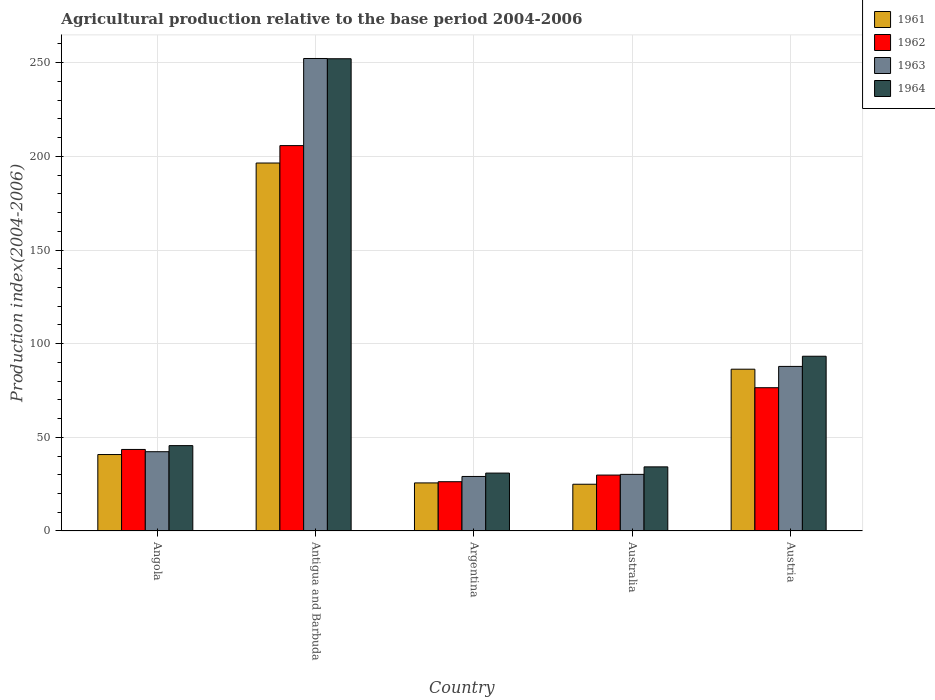How many different coloured bars are there?
Provide a succinct answer. 4. Are the number of bars on each tick of the X-axis equal?
Offer a very short reply. Yes. What is the label of the 1st group of bars from the left?
Make the answer very short. Angola. In how many cases, is the number of bars for a given country not equal to the number of legend labels?
Offer a terse response. 0. What is the agricultural production index in 1963 in Argentina?
Ensure brevity in your answer.  29.11. Across all countries, what is the maximum agricultural production index in 1964?
Ensure brevity in your answer.  252.1. Across all countries, what is the minimum agricultural production index in 1964?
Keep it short and to the point. 30.91. In which country was the agricultural production index in 1961 maximum?
Your answer should be compact. Antigua and Barbuda. What is the total agricultural production index in 1962 in the graph?
Provide a succinct answer. 381.91. What is the difference between the agricultural production index in 1961 in Argentina and that in Austria?
Offer a very short reply. -60.7. What is the difference between the agricultural production index in 1964 in Antigua and Barbuda and the agricultural production index in 1963 in Argentina?
Ensure brevity in your answer.  222.99. What is the average agricultural production index in 1963 per country?
Ensure brevity in your answer.  88.35. What is the difference between the agricultural production index of/in 1963 and agricultural production index of/in 1962 in Australia?
Your response must be concise. 0.38. What is the ratio of the agricultural production index in 1964 in Angola to that in Argentina?
Provide a short and direct response. 1.47. Is the difference between the agricultural production index in 1963 in Argentina and Australia greater than the difference between the agricultural production index in 1962 in Argentina and Australia?
Keep it short and to the point. Yes. What is the difference between the highest and the second highest agricultural production index in 1962?
Ensure brevity in your answer.  -32.96. What is the difference between the highest and the lowest agricultural production index in 1961?
Provide a succinct answer. 171.47. In how many countries, is the agricultural production index in 1964 greater than the average agricultural production index in 1964 taken over all countries?
Ensure brevity in your answer.  2. What does the 4th bar from the right in Argentina represents?
Your answer should be compact. 1961. Is it the case that in every country, the sum of the agricultural production index in 1961 and agricultural production index in 1963 is greater than the agricultural production index in 1964?
Provide a succinct answer. Yes. How many bars are there?
Your response must be concise. 20. What is the difference between two consecutive major ticks on the Y-axis?
Your answer should be compact. 50. Where does the legend appear in the graph?
Provide a short and direct response. Top right. What is the title of the graph?
Your answer should be compact. Agricultural production relative to the base period 2004-2006. What is the label or title of the X-axis?
Make the answer very short. Country. What is the label or title of the Y-axis?
Provide a succinct answer. Production index(2004-2006). What is the Production index(2004-2006) in 1961 in Angola?
Ensure brevity in your answer.  40.81. What is the Production index(2004-2006) of 1962 in Angola?
Ensure brevity in your answer.  43.53. What is the Production index(2004-2006) in 1963 in Angola?
Offer a terse response. 42.32. What is the Production index(2004-2006) in 1964 in Angola?
Keep it short and to the point. 45.58. What is the Production index(2004-2006) in 1961 in Antigua and Barbuda?
Ensure brevity in your answer.  196.43. What is the Production index(2004-2006) of 1962 in Antigua and Barbuda?
Give a very brief answer. 205.73. What is the Production index(2004-2006) in 1963 in Antigua and Barbuda?
Your answer should be very brief. 252.23. What is the Production index(2004-2006) of 1964 in Antigua and Barbuda?
Keep it short and to the point. 252.1. What is the Production index(2004-2006) in 1961 in Argentina?
Your answer should be very brief. 25.67. What is the Production index(2004-2006) of 1962 in Argentina?
Your answer should be compact. 26.31. What is the Production index(2004-2006) in 1963 in Argentina?
Offer a terse response. 29.11. What is the Production index(2004-2006) in 1964 in Argentina?
Your answer should be very brief. 30.91. What is the Production index(2004-2006) of 1961 in Australia?
Make the answer very short. 24.96. What is the Production index(2004-2006) of 1962 in Australia?
Offer a very short reply. 29.85. What is the Production index(2004-2006) of 1963 in Australia?
Provide a short and direct response. 30.23. What is the Production index(2004-2006) of 1964 in Australia?
Your answer should be compact. 34.23. What is the Production index(2004-2006) of 1961 in Austria?
Provide a short and direct response. 86.37. What is the Production index(2004-2006) of 1962 in Austria?
Provide a succinct answer. 76.49. What is the Production index(2004-2006) in 1963 in Austria?
Provide a succinct answer. 87.86. What is the Production index(2004-2006) of 1964 in Austria?
Ensure brevity in your answer.  93.29. Across all countries, what is the maximum Production index(2004-2006) in 1961?
Make the answer very short. 196.43. Across all countries, what is the maximum Production index(2004-2006) in 1962?
Provide a short and direct response. 205.73. Across all countries, what is the maximum Production index(2004-2006) of 1963?
Provide a succinct answer. 252.23. Across all countries, what is the maximum Production index(2004-2006) of 1964?
Provide a succinct answer. 252.1. Across all countries, what is the minimum Production index(2004-2006) of 1961?
Keep it short and to the point. 24.96. Across all countries, what is the minimum Production index(2004-2006) of 1962?
Give a very brief answer. 26.31. Across all countries, what is the minimum Production index(2004-2006) of 1963?
Offer a very short reply. 29.11. Across all countries, what is the minimum Production index(2004-2006) in 1964?
Keep it short and to the point. 30.91. What is the total Production index(2004-2006) in 1961 in the graph?
Ensure brevity in your answer.  374.24. What is the total Production index(2004-2006) of 1962 in the graph?
Ensure brevity in your answer.  381.91. What is the total Production index(2004-2006) of 1963 in the graph?
Ensure brevity in your answer.  441.75. What is the total Production index(2004-2006) of 1964 in the graph?
Provide a short and direct response. 456.11. What is the difference between the Production index(2004-2006) in 1961 in Angola and that in Antigua and Barbuda?
Keep it short and to the point. -155.62. What is the difference between the Production index(2004-2006) in 1962 in Angola and that in Antigua and Barbuda?
Your answer should be very brief. -162.2. What is the difference between the Production index(2004-2006) in 1963 in Angola and that in Antigua and Barbuda?
Provide a short and direct response. -209.91. What is the difference between the Production index(2004-2006) in 1964 in Angola and that in Antigua and Barbuda?
Offer a terse response. -206.52. What is the difference between the Production index(2004-2006) of 1961 in Angola and that in Argentina?
Make the answer very short. 15.14. What is the difference between the Production index(2004-2006) of 1962 in Angola and that in Argentina?
Make the answer very short. 17.22. What is the difference between the Production index(2004-2006) in 1963 in Angola and that in Argentina?
Your response must be concise. 13.21. What is the difference between the Production index(2004-2006) of 1964 in Angola and that in Argentina?
Your answer should be very brief. 14.67. What is the difference between the Production index(2004-2006) in 1961 in Angola and that in Australia?
Your response must be concise. 15.85. What is the difference between the Production index(2004-2006) of 1962 in Angola and that in Australia?
Your response must be concise. 13.68. What is the difference between the Production index(2004-2006) of 1963 in Angola and that in Australia?
Ensure brevity in your answer.  12.09. What is the difference between the Production index(2004-2006) of 1964 in Angola and that in Australia?
Offer a very short reply. 11.35. What is the difference between the Production index(2004-2006) in 1961 in Angola and that in Austria?
Your response must be concise. -45.56. What is the difference between the Production index(2004-2006) in 1962 in Angola and that in Austria?
Provide a short and direct response. -32.96. What is the difference between the Production index(2004-2006) of 1963 in Angola and that in Austria?
Ensure brevity in your answer.  -45.54. What is the difference between the Production index(2004-2006) of 1964 in Angola and that in Austria?
Your answer should be compact. -47.71. What is the difference between the Production index(2004-2006) of 1961 in Antigua and Barbuda and that in Argentina?
Your answer should be compact. 170.76. What is the difference between the Production index(2004-2006) in 1962 in Antigua and Barbuda and that in Argentina?
Your response must be concise. 179.42. What is the difference between the Production index(2004-2006) of 1963 in Antigua and Barbuda and that in Argentina?
Give a very brief answer. 223.12. What is the difference between the Production index(2004-2006) in 1964 in Antigua and Barbuda and that in Argentina?
Provide a succinct answer. 221.19. What is the difference between the Production index(2004-2006) in 1961 in Antigua and Barbuda and that in Australia?
Your answer should be very brief. 171.47. What is the difference between the Production index(2004-2006) in 1962 in Antigua and Barbuda and that in Australia?
Offer a very short reply. 175.88. What is the difference between the Production index(2004-2006) of 1963 in Antigua and Barbuda and that in Australia?
Offer a very short reply. 222. What is the difference between the Production index(2004-2006) in 1964 in Antigua and Barbuda and that in Australia?
Your answer should be very brief. 217.87. What is the difference between the Production index(2004-2006) of 1961 in Antigua and Barbuda and that in Austria?
Make the answer very short. 110.06. What is the difference between the Production index(2004-2006) in 1962 in Antigua and Barbuda and that in Austria?
Provide a succinct answer. 129.24. What is the difference between the Production index(2004-2006) in 1963 in Antigua and Barbuda and that in Austria?
Your response must be concise. 164.37. What is the difference between the Production index(2004-2006) in 1964 in Antigua and Barbuda and that in Austria?
Your answer should be compact. 158.81. What is the difference between the Production index(2004-2006) in 1961 in Argentina and that in Australia?
Your answer should be very brief. 0.71. What is the difference between the Production index(2004-2006) in 1962 in Argentina and that in Australia?
Your response must be concise. -3.54. What is the difference between the Production index(2004-2006) of 1963 in Argentina and that in Australia?
Keep it short and to the point. -1.12. What is the difference between the Production index(2004-2006) in 1964 in Argentina and that in Australia?
Ensure brevity in your answer.  -3.32. What is the difference between the Production index(2004-2006) of 1961 in Argentina and that in Austria?
Make the answer very short. -60.7. What is the difference between the Production index(2004-2006) in 1962 in Argentina and that in Austria?
Make the answer very short. -50.18. What is the difference between the Production index(2004-2006) of 1963 in Argentina and that in Austria?
Offer a terse response. -58.75. What is the difference between the Production index(2004-2006) of 1964 in Argentina and that in Austria?
Keep it short and to the point. -62.38. What is the difference between the Production index(2004-2006) in 1961 in Australia and that in Austria?
Keep it short and to the point. -61.41. What is the difference between the Production index(2004-2006) in 1962 in Australia and that in Austria?
Your answer should be compact. -46.64. What is the difference between the Production index(2004-2006) in 1963 in Australia and that in Austria?
Keep it short and to the point. -57.63. What is the difference between the Production index(2004-2006) of 1964 in Australia and that in Austria?
Provide a short and direct response. -59.06. What is the difference between the Production index(2004-2006) in 1961 in Angola and the Production index(2004-2006) in 1962 in Antigua and Barbuda?
Provide a succinct answer. -164.92. What is the difference between the Production index(2004-2006) of 1961 in Angola and the Production index(2004-2006) of 1963 in Antigua and Barbuda?
Make the answer very short. -211.42. What is the difference between the Production index(2004-2006) of 1961 in Angola and the Production index(2004-2006) of 1964 in Antigua and Barbuda?
Offer a terse response. -211.29. What is the difference between the Production index(2004-2006) in 1962 in Angola and the Production index(2004-2006) in 1963 in Antigua and Barbuda?
Offer a terse response. -208.7. What is the difference between the Production index(2004-2006) of 1962 in Angola and the Production index(2004-2006) of 1964 in Antigua and Barbuda?
Provide a short and direct response. -208.57. What is the difference between the Production index(2004-2006) in 1963 in Angola and the Production index(2004-2006) in 1964 in Antigua and Barbuda?
Provide a short and direct response. -209.78. What is the difference between the Production index(2004-2006) in 1961 in Angola and the Production index(2004-2006) in 1963 in Argentina?
Provide a succinct answer. 11.7. What is the difference between the Production index(2004-2006) in 1961 in Angola and the Production index(2004-2006) in 1964 in Argentina?
Your answer should be very brief. 9.9. What is the difference between the Production index(2004-2006) in 1962 in Angola and the Production index(2004-2006) in 1963 in Argentina?
Offer a terse response. 14.42. What is the difference between the Production index(2004-2006) in 1962 in Angola and the Production index(2004-2006) in 1964 in Argentina?
Your answer should be compact. 12.62. What is the difference between the Production index(2004-2006) in 1963 in Angola and the Production index(2004-2006) in 1964 in Argentina?
Offer a terse response. 11.41. What is the difference between the Production index(2004-2006) in 1961 in Angola and the Production index(2004-2006) in 1962 in Australia?
Give a very brief answer. 10.96. What is the difference between the Production index(2004-2006) of 1961 in Angola and the Production index(2004-2006) of 1963 in Australia?
Your answer should be compact. 10.58. What is the difference between the Production index(2004-2006) of 1961 in Angola and the Production index(2004-2006) of 1964 in Australia?
Keep it short and to the point. 6.58. What is the difference between the Production index(2004-2006) of 1963 in Angola and the Production index(2004-2006) of 1964 in Australia?
Your answer should be very brief. 8.09. What is the difference between the Production index(2004-2006) in 1961 in Angola and the Production index(2004-2006) in 1962 in Austria?
Give a very brief answer. -35.68. What is the difference between the Production index(2004-2006) in 1961 in Angola and the Production index(2004-2006) in 1963 in Austria?
Make the answer very short. -47.05. What is the difference between the Production index(2004-2006) in 1961 in Angola and the Production index(2004-2006) in 1964 in Austria?
Ensure brevity in your answer.  -52.48. What is the difference between the Production index(2004-2006) of 1962 in Angola and the Production index(2004-2006) of 1963 in Austria?
Your answer should be very brief. -44.33. What is the difference between the Production index(2004-2006) of 1962 in Angola and the Production index(2004-2006) of 1964 in Austria?
Keep it short and to the point. -49.76. What is the difference between the Production index(2004-2006) in 1963 in Angola and the Production index(2004-2006) in 1964 in Austria?
Your answer should be compact. -50.97. What is the difference between the Production index(2004-2006) of 1961 in Antigua and Barbuda and the Production index(2004-2006) of 1962 in Argentina?
Offer a terse response. 170.12. What is the difference between the Production index(2004-2006) in 1961 in Antigua and Barbuda and the Production index(2004-2006) in 1963 in Argentina?
Your answer should be compact. 167.32. What is the difference between the Production index(2004-2006) of 1961 in Antigua and Barbuda and the Production index(2004-2006) of 1964 in Argentina?
Your answer should be compact. 165.52. What is the difference between the Production index(2004-2006) in 1962 in Antigua and Barbuda and the Production index(2004-2006) in 1963 in Argentina?
Your response must be concise. 176.62. What is the difference between the Production index(2004-2006) of 1962 in Antigua and Barbuda and the Production index(2004-2006) of 1964 in Argentina?
Ensure brevity in your answer.  174.82. What is the difference between the Production index(2004-2006) in 1963 in Antigua and Barbuda and the Production index(2004-2006) in 1964 in Argentina?
Your answer should be compact. 221.32. What is the difference between the Production index(2004-2006) in 1961 in Antigua and Barbuda and the Production index(2004-2006) in 1962 in Australia?
Give a very brief answer. 166.58. What is the difference between the Production index(2004-2006) in 1961 in Antigua and Barbuda and the Production index(2004-2006) in 1963 in Australia?
Give a very brief answer. 166.2. What is the difference between the Production index(2004-2006) in 1961 in Antigua and Barbuda and the Production index(2004-2006) in 1964 in Australia?
Your answer should be very brief. 162.2. What is the difference between the Production index(2004-2006) of 1962 in Antigua and Barbuda and the Production index(2004-2006) of 1963 in Australia?
Keep it short and to the point. 175.5. What is the difference between the Production index(2004-2006) in 1962 in Antigua and Barbuda and the Production index(2004-2006) in 1964 in Australia?
Your answer should be compact. 171.5. What is the difference between the Production index(2004-2006) of 1963 in Antigua and Barbuda and the Production index(2004-2006) of 1964 in Australia?
Offer a terse response. 218. What is the difference between the Production index(2004-2006) in 1961 in Antigua and Barbuda and the Production index(2004-2006) in 1962 in Austria?
Ensure brevity in your answer.  119.94. What is the difference between the Production index(2004-2006) in 1961 in Antigua and Barbuda and the Production index(2004-2006) in 1963 in Austria?
Provide a succinct answer. 108.57. What is the difference between the Production index(2004-2006) in 1961 in Antigua and Barbuda and the Production index(2004-2006) in 1964 in Austria?
Offer a terse response. 103.14. What is the difference between the Production index(2004-2006) in 1962 in Antigua and Barbuda and the Production index(2004-2006) in 1963 in Austria?
Provide a short and direct response. 117.87. What is the difference between the Production index(2004-2006) in 1962 in Antigua and Barbuda and the Production index(2004-2006) in 1964 in Austria?
Your response must be concise. 112.44. What is the difference between the Production index(2004-2006) of 1963 in Antigua and Barbuda and the Production index(2004-2006) of 1964 in Austria?
Your response must be concise. 158.94. What is the difference between the Production index(2004-2006) of 1961 in Argentina and the Production index(2004-2006) of 1962 in Australia?
Provide a short and direct response. -4.18. What is the difference between the Production index(2004-2006) in 1961 in Argentina and the Production index(2004-2006) in 1963 in Australia?
Provide a short and direct response. -4.56. What is the difference between the Production index(2004-2006) in 1961 in Argentina and the Production index(2004-2006) in 1964 in Australia?
Your answer should be compact. -8.56. What is the difference between the Production index(2004-2006) in 1962 in Argentina and the Production index(2004-2006) in 1963 in Australia?
Keep it short and to the point. -3.92. What is the difference between the Production index(2004-2006) of 1962 in Argentina and the Production index(2004-2006) of 1964 in Australia?
Provide a short and direct response. -7.92. What is the difference between the Production index(2004-2006) of 1963 in Argentina and the Production index(2004-2006) of 1964 in Australia?
Keep it short and to the point. -5.12. What is the difference between the Production index(2004-2006) of 1961 in Argentina and the Production index(2004-2006) of 1962 in Austria?
Offer a terse response. -50.82. What is the difference between the Production index(2004-2006) in 1961 in Argentina and the Production index(2004-2006) in 1963 in Austria?
Ensure brevity in your answer.  -62.19. What is the difference between the Production index(2004-2006) in 1961 in Argentina and the Production index(2004-2006) in 1964 in Austria?
Ensure brevity in your answer.  -67.62. What is the difference between the Production index(2004-2006) of 1962 in Argentina and the Production index(2004-2006) of 1963 in Austria?
Offer a very short reply. -61.55. What is the difference between the Production index(2004-2006) in 1962 in Argentina and the Production index(2004-2006) in 1964 in Austria?
Your response must be concise. -66.98. What is the difference between the Production index(2004-2006) in 1963 in Argentina and the Production index(2004-2006) in 1964 in Austria?
Give a very brief answer. -64.18. What is the difference between the Production index(2004-2006) in 1961 in Australia and the Production index(2004-2006) in 1962 in Austria?
Provide a short and direct response. -51.53. What is the difference between the Production index(2004-2006) of 1961 in Australia and the Production index(2004-2006) of 1963 in Austria?
Give a very brief answer. -62.9. What is the difference between the Production index(2004-2006) in 1961 in Australia and the Production index(2004-2006) in 1964 in Austria?
Ensure brevity in your answer.  -68.33. What is the difference between the Production index(2004-2006) in 1962 in Australia and the Production index(2004-2006) in 1963 in Austria?
Your answer should be very brief. -58.01. What is the difference between the Production index(2004-2006) in 1962 in Australia and the Production index(2004-2006) in 1964 in Austria?
Your response must be concise. -63.44. What is the difference between the Production index(2004-2006) in 1963 in Australia and the Production index(2004-2006) in 1964 in Austria?
Keep it short and to the point. -63.06. What is the average Production index(2004-2006) in 1961 per country?
Your response must be concise. 74.85. What is the average Production index(2004-2006) of 1962 per country?
Offer a terse response. 76.38. What is the average Production index(2004-2006) in 1963 per country?
Your answer should be very brief. 88.35. What is the average Production index(2004-2006) in 1964 per country?
Your answer should be very brief. 91.22. What is the difference between the Production index(2004-2006) in 1961 and Production index(2004-2006) in 1962 in Angola?
Provide a succinct answer. -2.72. What is the difference between the Production index(2004-2006) of 1961 and Production index(2004-2006) of 1963 in Angola?
Make the answer very short. -1.51. What is the difference between the Production index(2004-2006) of 1961 and Production index(2004-2006) of 1964 in Angola?
Provide a succinct answer. -4.77. What is the difference between the Production index(2004-2006) of 1962 and Production index(2004-2006) of 1963 in Angola?
Make the answer very short. 1.21. What is the difference between the Production index(2004-2006) of 1962 and Production index(2004-2006) of 1964 in Angola?
Keep it short and to the point. -2.05. What is the difference between the Production index(2004-2006) of 1963 and Production index(2004-2006) of 1964 in Angola?
Offer a very short reply. -3.26. What is the difference between the Production index(2004-2006) of 1961 and Production index(2004-2006) of 1963 in Antigua and Barbuda?
Offer a very short reply. -55.8. What is the difference between the Production index(2004-2006) in 1961 and Production index(2004-2006) in 1964 in Antigua and Barbuda?
Offer a very short reply. -55.67. What is the difference between the Production index(2004-2006) of 1962 and Production index(2004-2006) of 1963 in Antigua and Barbuda?
Give a very brief answer. -46.5. What is the difference between the Production index(2004-2006) of 1962 and Production index(2004-2006) of 1964 in Antigua and Barbuda?
Offer a terse response. -46.37. What is the difference between the Production index(2004-2006) of 1963 and Production index(2004-2006) of 1964 in Antigua and Barbuda?
Offer a very short reply. 0.13. What is the difference between the Production index(2004-2006) of 1961 and Production index(2004-2006) of 1962 in Argentina?
Give a very brief answer. -0.64. What is the difference between the Production index(2004-2006) in 1961 and Production index(2004-2006) in 1963 in Argentina?
Your answer should be compact. -3.44. What is the difference between the Production index(2004-2006) in 1961 and Production index(2004-2006) in 1964 in Argentina?
Make the answer very short. -5.24. What is the difference between the Production index(2004-2006) of 1962 and Production index(2004-2006) of 1963 in Argentina?
Provide a succinct answer. -2.8. What is the difference between the Production index(2004-2006) of 1962 and Production index(2004-2006) of 1964 in Argentina?
Offer a terse response. -4.6. What is the difference between the Production index(2004-2006) in 1961 and Production index(2004-2006) in 1962 in Australia?
Provide a short and direct response. -4.89. What is the difference between the Production index(2004-2006) in 1961 and Production index(2004-2006) in 1963 in Australia?
Keep it short and to the point. -5.27. What is the difference between the Production index(2004-2006) of 1961 and Production index(2004-2006) of 1964 in Australia?
Give a very brief answer. -9.27. What is the difference between the Production index(2004-2006) in 1962 and Production index(2004-2006) in 1963 in Australia?
Provide a short and direct response. -0.38. What is the difference between the Production index(2004-2006) in 1962 and Production index(2004-2006) in 1964 in Australia?
Offer a very short reply. -4.38. What is the difference between the Production index(2004-2006) of 1963 and Production index(2004-2006) of 1964 in Australia?
Make the answer very short. -4. What is the difference between the Production index(2004-2006) of 1961 and Production index(2004-2006) of 1962 in Austria?
Ensure brevity in your answer.  9.88. What is the difference between the Production index(2004-2006) in 1961 and Production index(2004-2006) in 1963 in Austria?
Offer a very short reply. -1.49. What is the difference between the Production index(2004-2006) of 1961 and Production index(2004-2006) of 1964 in Austria?
Provide a short and direct response. -6.92. What is the difference between the Production index(2004-2006) of 1962 and Production index(2004-2006) of 1963 in Austria?
Keep it short and to the point. -11.37. What is the difference between the Production index(2004-2006) of 1962 and Production index(2004-2006) of 1964 in Austria?
Provide a short and direct response. -16.8. What is the difference between the Production index(2004-2006) of 1963 and Production index(2004-2006) of 1964 in Austria?
Ensure brevity in your answer.  -5.43. What is the ratio of the Production index(2004-2006) in 1961 in Angola to that in Antigua and Barbuda?
Offer a terse response. 0.21. What is the ratio of the Production index(2004-2006) of 1962 in Angola to that in Antigua and Barbuda?
Keep it short and to the point. 0.21. What is the ratio of the Production index(2004-2006) of 1963 in Angola to that in Antigua and Barbuda?
Offer a very short reply. 0.17. What is the ratio of the Production index(2004-2006) of 1964 in Angola to that in Antigua and Barbuda?
Give a very brief answer. 0.18. What is the ratio of the Production index(2004-2006) of 1961 in Angola to that in Argentina?
Provide a short and direct response. 1.59. What is the ratio of the Production index(2004-2006) of 1962 in Angola to that in Argentina?
Keep it short and to the point. 1.65. What is the ratio of the Production index(2004-2006) of 1963 in Angola to that in Argentina?
Your answer should be compact. 1.45. What is the ratio of the Production index(2004-2006) of 1964 in Angola to that in Argentina?
Give a very brief answer. 1.47. What is the ratio of the Production index(2004-2006) of 1961 in Angola to that in Australia?
Make the answer very short. 1.64. What is the ratio of the Production index(2004-2006) of 1962 in Angola to that in Australia?
Your response must be concise. 1.46. What is the ratio of the Production index(2004-2006) in 1963 in Angola to that in Australia?
Keep it short and to the point. 1.4. What is the ratio of the Production index(2004-2006) of 1964 in Angola to that in Australia?
Give a very brief answer. 1.33. What is the ratio of the Production index(2004-2006) in 1961 in Angola to that in Austria?
Provide a succinct answer. 0.47. What is the ratio of the Production index(2004-2006) of 1962 in Angola to that in Austria?
Ensure brevity in your answer.  0.57. What is the ratio of the Production index(2004-2006) in 1963 in Angola to that in Austria?
Provide a short and direct response. 0.48. What is the ratio of the Production index(2004-2006) in 1964 in Angola to that in Austria?
Offer a terse response. 0.49. What is the ratio of the Production index(2004-2006) of 1961 in Antigua and Barbuda to that in Argentina?
Offer a terse response. 7.65. What is the ratio of the Production index(2004-2006) of 1962 in Antigua and Barbuda to that in Argentina?
Offer a very short reply. 7.82. What is the ratio of the Production index(2004-2006) in 1963 in Antigua and Barbuda to that in Argentina?
Keep it short and to the point. 8.66. What is the ratio of the Production index(2004-2006) of 1964 in Antigua and Barbuda to that in Argentina?
Offer a terse response. 8.16. What is the ratio of the Production index(2004-2006) of 1961 in Antigua and Barbuda to that in Australia?
Make the answer very short. 7.87. What is the ratio of the Production index(2004-2006) of 1962 in Antigua and Barbuda to that in Australia?
Offer a terse response. 6.89. What is the ratio of the Production index(2004-2006) of 1963 in Antigua and Barbuda to that in Australia?
Offer a terse response. 8.34. What is the ratio of the Production index(2004-2006) of 1964 in Antigua and Barbuda to that in Australia?
Your answer should be compact. 7.36. What is the ratio of the Production index(2004-2006) of 1961 in Antigua and Barbuda to that in Austria?
Offer a very short reply. 2.27. What is the ratio of the Production index(2004-2006) in 1962 in Antigua and Barbuda to that in Austria?
Your response must be concise. 2.69. What is the ratio of the Production index(2004-2006) in 1963 in Antigua and Barbuda to that in Austria?
Make the answer very short. 2.87. What is the ratio of the Production index(2004-2006) in 1964 in Antigua and Barbuda to that in Austria?
Provide a short and direct response. 2.7. What is the ratio of the Production index(2004-2006) of 1961 in Argentina to that in Australia?
Offer a very short reply. 1.03. What is the ratio of the Production index(2004-2006) in 1962 in Argentina to that in Australia?
Offer a terse response. 0.88. What is the ratio of the Production index(2004-2006) of 1963 in Argentina to that in Australia?
Give a very brief answer. 0.96. What is the ratio of the Production index(2004-2006) in 1964 in Argentina to that in Australia?
Provide a succinct answer. 0.9. What is the ratio of the Production index(2004-2006) of 1961 in Argentina to that in Austria?
Keep it short and to the point. 0.3. What is the ratio of the Production index(2004-2006) of 1962 in Argentina to that in Austria?
Offer a terse response. 0.34. What is the ratio of the Production index(2004-2006) of 1963 in Argentina to that in Austria?
Your answer should be compact. 0.33. What is the ratio of the Production index(2004-2006) of 1964 in Argentina to that in Austria?
Offer a very short reply. 0.33. What is the ratio of the Production index(2004-2006) of 1961 in Australia to that in Austria?
Your answer should be very brief. 0.29. What is the ratio of the Production index(2004-2006) of 1962 in Australia to that in Austria?
Provide a succinct answer. 0.39. What is the ratio of the Production index(2004-2006) of 1963 in Australia to that in Austria?
Keep it short and to the point. 0.34. What is the ratio of the Production index(2004-2006) of 1964 in Australia to that in Austria?
Make the answer very short. 0.37. What is the difference between the highest and the second highest Production index(2004-2006) of 1961?
Keep it short and to the point. 110.06. What is the difference between the highest and the second highest Production index(2004-2006) in 1962?
Make the answer very short. 129.24. What is the difference between the highest and the second highest Production index(2004-2006) in 1963?
Ensure brevity in your answer.  164.37. What is the difference between the highest and the second highest Production index(2004-2006) in 1964?
Give a very brief answer. 158.81. What is the difference between the highest and the lowest Production index(2004-2006) of 1961?
Make the answer very short. 171.47. What is the difference between the highest and the lowest Production index(2004-2006) of 1962?
Your answer should be compact. 179.42. What is the difference between the highest and the lowest Production index(2004-2006) in 1963?
Keep it short and to the point. 223.12. What is the difference between the highest and the lowest Production index(2004-2006) of 1964?
Offer a terse response. 221.19. 